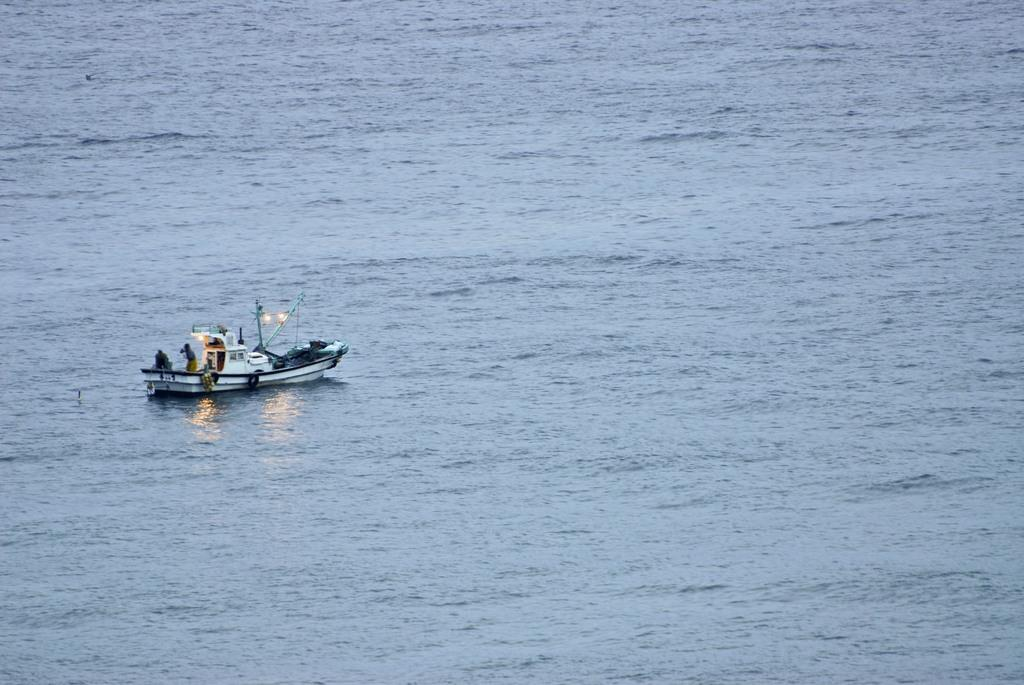What is the primary element in the image? There is water in the image. What can be seen on the left side of the image? There is a boat on the left side of the image. How many people are in the boat? There are two persons in the boat. What type of mark can be seen on the boat in the image? There is no specific mark mentioned or visible on the boat in the image. What kind of laborer is working on the boat in the image? There are no laborers present in the image, only two persons in the boat. 